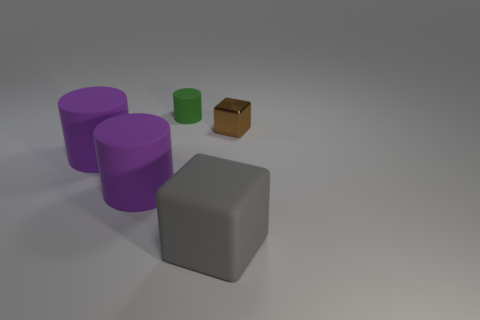There is a gray thing that is the same shape as the brown object; what size is it?
Make the answer very short. Large. Is there any other thing that is the same size as the shiny cube?
Provide a succinct answer. Yes. What number of other things are the same color as the small metallic block?
Offer a terse response. 0. How many cubes are either tiny red things or tiny green objects?
Ensure brevity in your answer.  0. What color is the object behind the brown object that is on the right side of the green matte cylinder?
Make the answer very short. Green. What is the shape of the green object?
Provide a succinct answer. Cylinder. There is a matte object that is on the right side of the green cylinder; is it the same size as the small brown shiny block?
Make the answer very short. No. Is there a large blue cylinder made of the same material as the brown cube?
Offer a very short reply. No. What number of objects are small objects that are left of the big gray rubber block or tiny cubes?
Your response must be concise. 2. Are any small cubes visible?
Make the answer very short. Yes. 